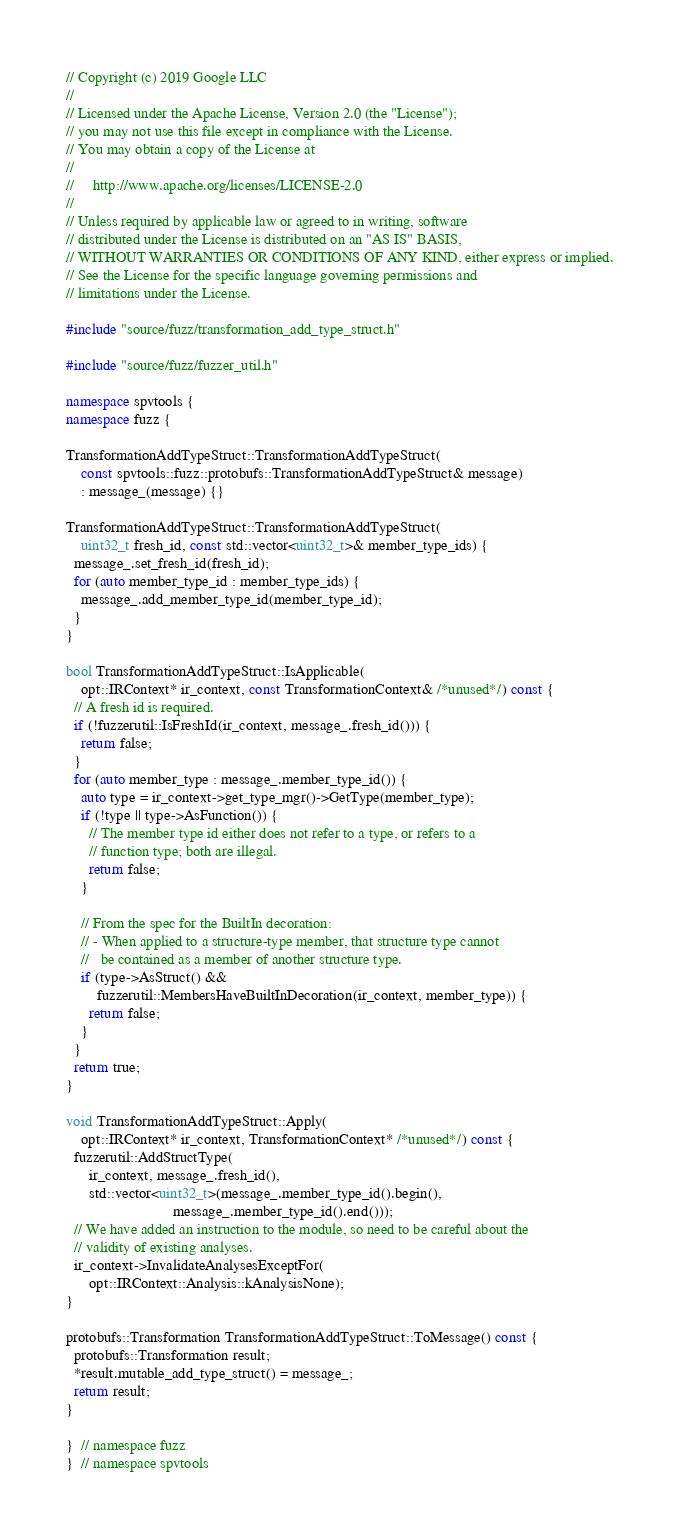<code> <loc_0><loc_0><loc_500><loc_500><_C++_>// Copyright (c) 2019 Google LLC
//
// Licensed under the Apache License, Version 2.0 (the "License");
// you may not use this file except in compliance with the License.
// You may obtain a copy of the License at
//
//     http://www.apache.org/licenses/LICENSE-2.0
//
// Unless required by applicable law or agreed to in writing, software
// distributed under the License is distributed on an "AS IS" BASIS,
// WITHOUT WARRANTIES OR CONDITIONS OF ANY KIND, either express or implied.
// See the License for the specific language governing permissions and
// limitations under the License.

#include "source/fuzz/transformation_add_type_struct.h"

#include "source/fuzz/fuzzer_util.h"

namespace spvtools {
namespace fuzz {

TransformationAddTypeStruct::TransformationAddTypeStruct(
    const spvtools::fuzz::protobufs::TransformationAddTypeStruct& message)
    : message_(message) {}

TransformationAddTypeStruct::TransformationAddTypeStruct(
    uint32_t fresh_id, const std::vector<uint32_t>& member_type_ids) {
  message_.set_fresh_id(fresh_id);
  for (auto member_type_id : member_type_ids) {
    message_.add_member_type_id(member_type_id);
  }
}

bool TransformationAddTypeStruct::IsApplicable(
    opt::IRContext* ir_context, const TransformationContext& /*unused*/) const {
  // A fresh id is required.
  if (!fuzzerutil::IsFreshId(ir_context, message_.fresh_id())) {
    return false;
  }
  for (auto member_type : message_.member_type_id()) {
    auto type = ir_context->get_type_mgr()->GetType(member_type);
    if (!type || type->AsFunction()) {
      // The member type id either does not refer to a type, or refers to a
      // function type; both are illegal.
      return false;
    }

    // From the spec for the BuiltIn decoration:
    // - When applied to a structure-type member, that structure type cannot
    //   be contained as a member of another structure type.
    if (type->AsStruct() &&
        fuzzerutil::MembersHaveBuiltInDecoration(ir_context, member_type)) {
      return false;
    }
  }
  return true;
}

void TransformationAddTypeStruct::Apply(
    opt::IRContext* ir_context, TransformationContext* /*unused*/) const {
  fuzzerutil::AddStructType(
      ir_context, message_.fresh_id(),
      std::vector<uint32_t>(message_.member_type_id().begin(),
                            message_.member_type_id().end()));
  // We have added an instruction to the module, so need to be careful about the
  // validity of existing analyses.
  ir_context->InvalidateAnalysesExceptFor(
      opt::IRContext::Analysis::kAnalysisNone);
}

protobufs::Transformation TransformationAddTypeStruct::ToMessage() const {
  protobufs::Transformation result;
  *result.mutable_add_type_struct() = message_;
  return result;
}

}  // namespace fuzz
}  // namespace spvtools
</code> 